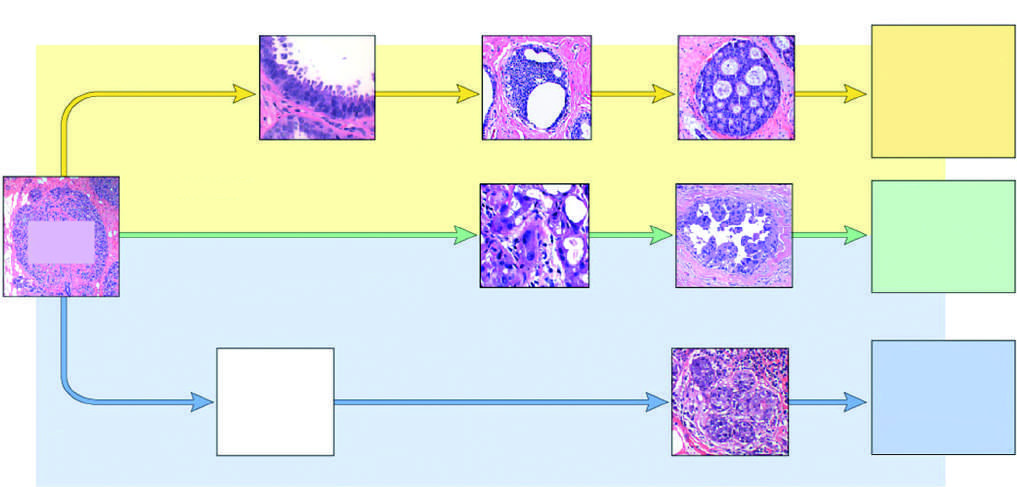what include flat epithelial atypia, adh, and dcis, all of which share certain genomic events with invasive er-positive carcinomas, such gains of chromosome 1, losses of chromosome 16, and mutations of pik3ca the gene encoding pi3k?
Answer the question using a single word or phrase. Morphologically recognized precursor lesions 